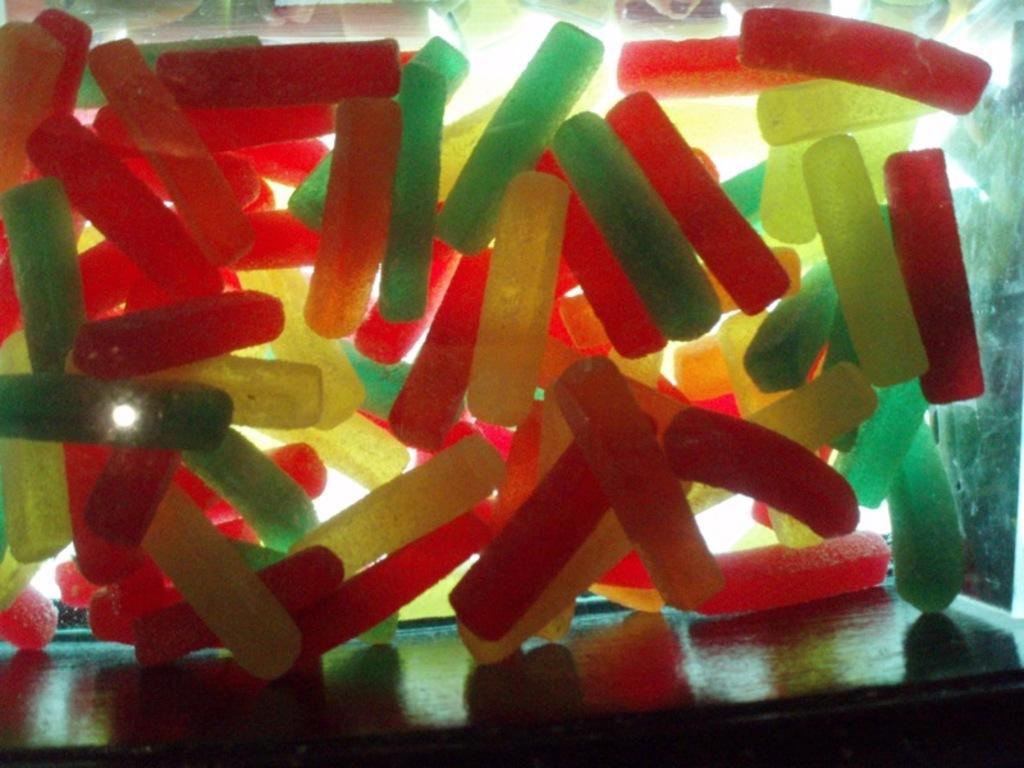What type of objects are present in the image? There are different colored plastic objects in the image. Can you describe the container in which the plastic objects are placed? The plastic objects appear to be inside a glass wooden box. What type of bread can be seen in the image? There is no bread present in the image; it features different colored plastic objects inside a glass wooden box. 